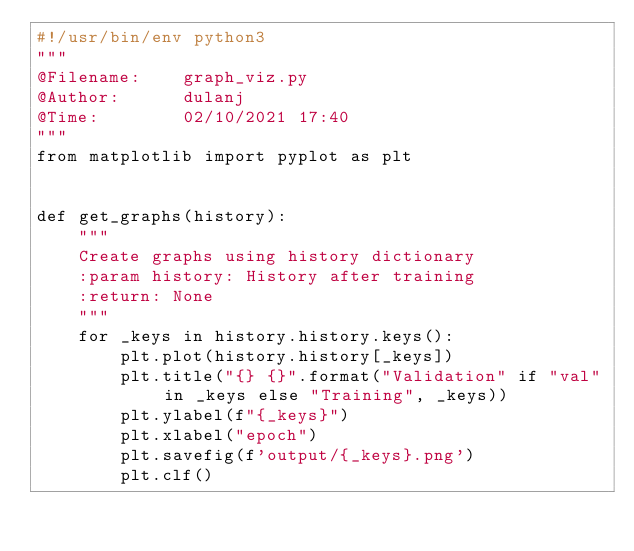<code> <loc_0><loc_0><loc_500><loc_500><_Python_>#!/usr/bin/env python3
"""
@Filename:    graph_viz.py
@Author:      dulanj
@Time:        02/10/2021 17:40
"""
from matplotlib import pyplot as plt


def get_graphs(history):
    """
    Create graphs using history dictionary
    :param history: History after training
    :return: None
    """
    for _keys in history.history.keys():
        plt.plot(history.history[_keys])
        plt.title("{} {}".format("Validation" if "val" in _keys else "Training", _keys))
        plt.ylabel(f"{_keys}")
        plt.xlabel("epoch")
        plt.savefig(f'output/{_keys}.png')
        plt.clf()
</code> 